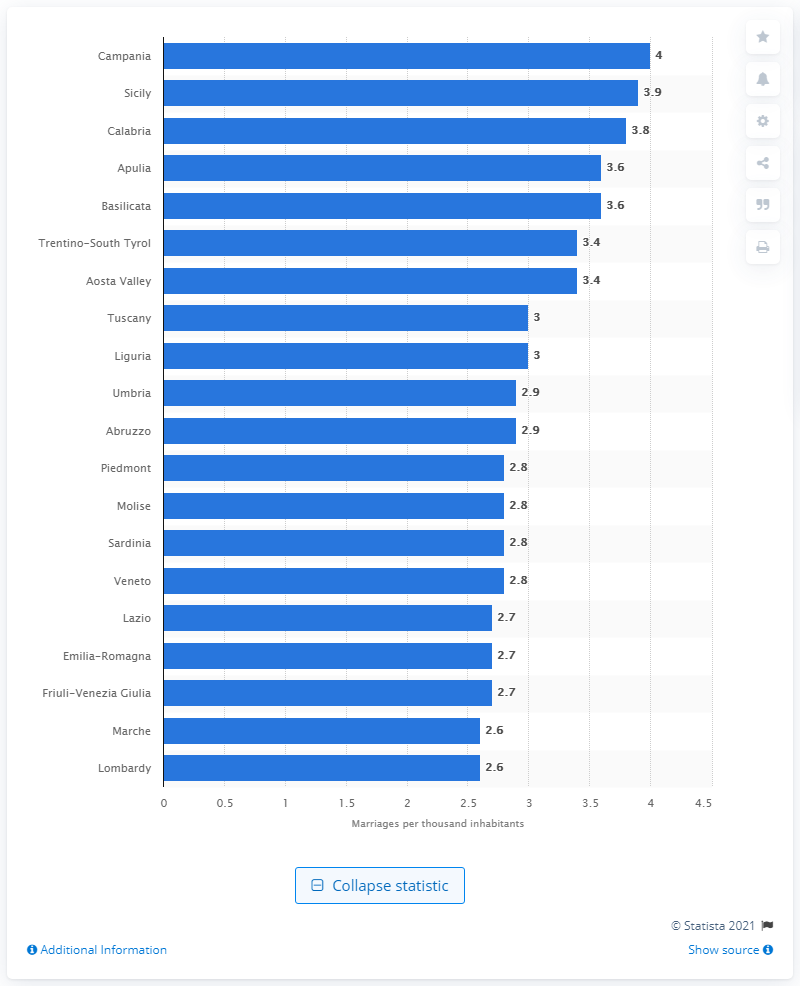Outline some significant characteristics in this image. The region with the lowest marriage rate was Sicily. The lowest marriage rate was recorded in the region of Marche in Lombardy. The region with the highest marriage rate was Campania. The lowest marriage rate was recorded in Lombardy. 